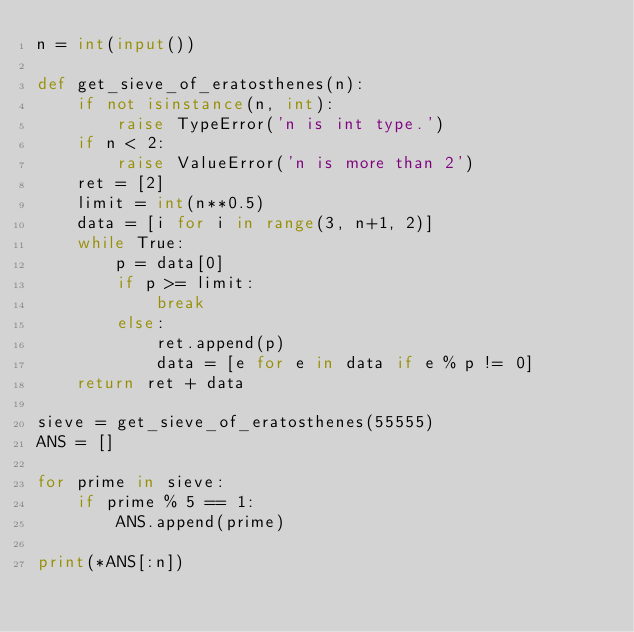Convert code to text. <code><loc_0><loc_0><loc_500><loc_500><_Python_>n = int(input())

def get_sieve_of_eratosthenes(n):
    if not isinstance(n, int):
        raise TypeError('n is int type.')
    if n < 2:
        raise ValueError('n is more than 2')
    ret = [2]
    limit = int(n**0.5)
    data = [i for i in range(3, n+1, 2)]
    while True:
        p = data[0]
        if p >= limit:
            break
        else:
            ret.append(p)
            data = [e for e in data if e % p != 0]
    return ret + data

sieve = get_sieve_of_eratosthenes(55555)
ANS = []

for prime in sieve:
    if prime % 5 == 1:
        ANS.append(prime)

print(*ANS[:n])</code> 